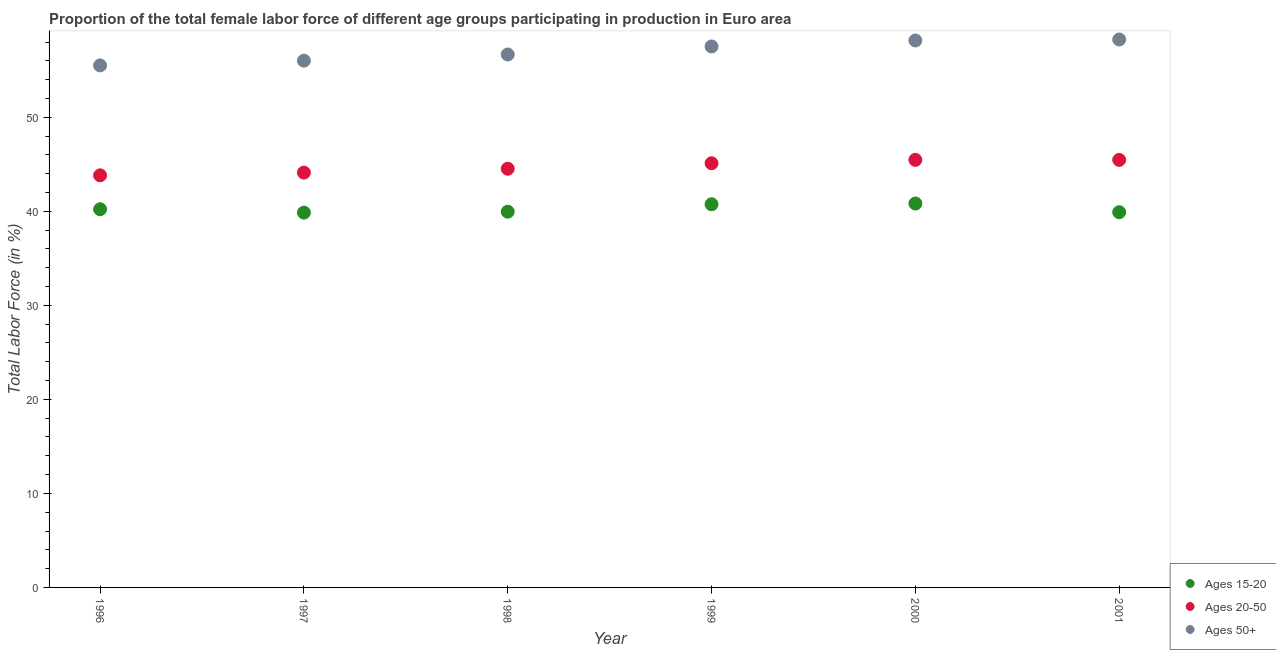What is the percentage of female labor force within the age group 15-20 in 2001?
Make the answer very short. 39.9. Across all years, what is the maximum percentage of female labor force within the age group 20-50?
Provide a short and direct response. 45.47. Across all years, what is the minimum percentage of female labor force within the age group 15-20?
Make the answer very short. 39.86. In which year was the percentage of female labor force above age 50 maximum?
Give a very brief answer. 2001. In which year was the percentage of female labor force within the age group 20-50 minimum?
Make the answer very short. 1996. What is the total percentage of female labor force within the age group 20-50 in the graph?
Ensure brevity in your answer.  268.5. What is the difference between the percentage of female labor force within the age group 15-20 in 1996 and that in 1998?
Ensure brevity in your answer.  0.26. What is the difference between the percentage of female labor force within the age group 15-20 in 2001 and the percentage of female labor force within the age group 20-50 in 1998?
Your answer should be compact. -4.62. What is the average percentage of female labor force above age 50 per year?
Make the answer very short. 57.03. In the year 2000, what is the difference between the percentage of female labor force above age 50 and percentage of female labor force within the age group 15-20?
Keep it short and to the point. 17.34. In how many years, is the percentage of female labor force within the age group 15-20 greater than 8 %?
Make the answer very short. 6. What is the ratio of the percentage of female labor force within the age group 20-50 in 1996 to that in 1999?
Provide a short and direct response. 0.97. What is the difference between the highest and the second highest percentage of female labor force above age 50?
Make the answer very short. 0.11. What is the difference between the highest and the lowest percentage of female labor force within the age group 20-50?
Your answer should be compact. 1.65. Is the sum of the percentage of female labor force within the age group 20-50 in 1998 and 1999 greater than the maximum percentage of female labor force within the age group 15-20 across all years?
Keep it short and to the point. Yes. Is it the case that in every year, the sum of the percentage of female labor force within the age group 15-20 and percentage of female labor force within the age group 20-50 is greater than the percentage of female labor force above age 50?
Your response must be concise. Yes. How many years are there in the graph?
Provide a short and direct response. 6. Are the values on the major ticks of Y-axis written in scientific E-notation?
Give a very brief answer. No. Does the graph contain any zero values?
Your response must be concise. No. Where does the legend appear in the graph?
Your response must be concise. Bottom right. How many legend labels are there?
Your response must be concise. 3. How are the legend labels stacked?
Offer a very short reply. Vertical. What is the title of the graph?
Provide a short and direct response. Proportion of the total female labor force of different age groups participating in production in Euro area. What is the label or title of the X-axis?
Give a very brief answer. Year. What is the label or title of the Y-axis?
Ensure brevity in your answer.  Total Labor Force (in %). What is the Total Labor Force (in %) of Ages 15-20 in 1996?
Your answer should be compact. 40.22. What is the Total Labor Force (in %) of Ages 20-50 in 1996?
Provide a succinct answer. 43.82. What is the Total Labor Force (in %) of Ages 50+ in 1996?
Provide a succinct answer. 55.51. What is the Total Labor Force (in %) of Ages 15-20 in 1997?
Provide a short and direct response. 39.86. What is the Total Labor Force (in %) in Ages 20-50 in 1997?
Provide a short and direct response. 44.11. What is the Total Labor Force (in %) of Ages 50+ in 1997?
Give a very brief answer. 56.02. What is the Total Labor Force (in %) in Ages 15-20 in 1998?
Ensure brevity in your answer.  39.96. What is the Total Labor Force (in %) of Ages 20-50 in 1998?
Offer a terse response. 44.52. What is the Total Labor Force (in %) of Ages 50+ in 1998?
Give a very brief answer. 56.67. What is the Total Labor Force (in %) of Ages 15-20 in 1999?
Provide a short and direct response. 40.75. What is the Total Labor Force (in %) in Ages 20-50 in 1999?
Offer a very short reply. 45.11. What is the Total Labor Force (in %) of Ages 50+ in 1999?
Offer a very short reply. 57.53. What is the Total Labor Force (in %) in Ages 15-20 in 2000?
Provide a short and direct response. 40.83. What is the Total Labor Force (in %) of Ages 20-50 in 2000?
Provide a succinct answer. 45.47. What is the Total Labor Force (in %) of Ages 50+ in 2000?
Provide a short and direct response. 58.16. What is the Total Labor Force (in %) of Ages 15-20 in 2001?
Make the answer very short. 39.9. What is the Total Labor Force (in %) in Ages 20-50 in 2001?
Ensure brevity in your answer.  45.46. What is the Total Labor Force (in %) of Ages 50+ in 2001?
Keep it short and to the point. 58.27. Across all years, what is the maximum Total Labor Force (in %) of Ages 15-20?
Provide a succinct answer. 40.83. Across all years, what is the maximum Total Labor Force (in %) of Ages 20-50?
Ensure brevity in your answer.  45.47. Across all years, what is the maximum Total Labor Force (in %) of Ages 50+?
Keep it short and to the point. 58.27. Across all years, what is the minimum Total Labor Force (in %) of Ages 15-20?
Offer a terse response. 39.86. Across all years, what is the minimum Total Labor Force (in %) of Ages 20-50?
Your answer should be very brief. 43.82. Across all years, what is the minimum Total Labor Force (in %) in Ages 50+?
Your answer should be compact. 55.51. What is the total Total Labor Force (in %) of Ages 15-20 in the graph?
Make the answer very short. 241.5. What is the total Total Labor Force (in %) of Ages 20-50 in the graph?
Your response must be concise. 268.5. What is the total Total Labor Force (in %) of Ages 50+ in the graph?
Provide a short and direct response. 342.15. What is the difference between the Total Labor Force (in %) in Ages 15-20 in 1996 and that in 1997?
Make the answer very short. 0.36. What is the difference between the Total Labor Force (in %) in Ages 20-50 in 1996 and that in 1997?
Ensure brevity in your answer.  -0.29. What is the difference between the Total Labor Force (in %) in Ages 50+ in 1996 and that in 1997?
Your response must be concise. -0.51. What is the difference between the Total Labor Force (in %) in Ages 15-20 in 1996 and that in 1998?
Your response must be concise. 0.26. What is the difference between the Total Labor Force (in %) in Ages 20-50 in 1996 and that in 1998?
Your response must be concise. -0.7. What is the difference between the Total Labor Force (in %) in Ages 50+ in 1996 and that in 1998?
Your answer should be compact. -1.16. What is the difference between the Total Labor Force (in %) of Ages 15-20 in 1996 and that in 1999?
Offer a terse response. -0.53. What is the difference between the Total Labor Force (in %) of Ages 20-50 in 1996 and that in 1999?
Offer a terse response. -1.28. What is the difference between the Total Labor Force (in %) of Ages 50+ in 1996 and that in 1999?
Offer a terse response. -2.02. What is the difference between the Total Labor Force (in %) in Ages 15-20 in 1996 and that in 2000?
Offer a terse response. -0.61. What is the difference between the Total Labor Force (in %) of Ages 20-50 in 1996 and that in 2000?
Keep it short and to the point. -1.65. What is the difference between the Total Labor Force (in %) of Ages 50+ in 1996 and that in 2000?
Make the answer very short. -2.65. What is the difference between the Total Labor Force (in %) in Ages 15-20 in 1996 and that in 2001?
Your response must be concise. 0.32. What is the difference between the Total Labor Force (in %) of Ages 20-50 in 1996 and that in 2001?
Give a very brief answer. -1.64. What is the difference between the Total Labor Force (in %) of Ages 50+ in 1996 and that in 2001?
Ensure brevity in your answer.  -2.76. What is the difference between the Total Labor Force (in %) in Ages 15-20 in 1997 and that in 1998?
Your answer should be compact. -0.1. What is the difference between the Total Labor Force (in %) of Ages 20-50 in 1997 and that in 1998?
Provide a short and direct response. -0.41. What is the difference between the Total Labor Force (in %) in Ages 50+ in 1997 and that in 1998?
Offer a terse response. -0.65. What is the difference between the Total Labor Force (in %) in Ages 15-20 in 1997 and that in 1999?
Your answer should be compact. -0.89. What is the difference between the Total Labor Force (in %) of Ages 20-50 in 1997 and that in 1999?
Offer a terse response. -0.99. What is the difference between the Total Labor Force (in %) of Ages 50+ in 1997 and that in 1999?
Offer a very short reply. -1.51. What is the difference between the Total Labor Force (in %) of Ages 15-20 in 1997 and that in 2000?
Your answer should be very brief. -0.97. What is the difference between the Total Labor Force (in %) of Ages 20-50 in 1997 and that in 2000?
Keep it short and to the point. -1.35. What is the difference between the Total Labor Force (in %) in Ages 50+ in 1997 and that in 2000?
Keep it short and to the point. -2.15. What is the difference between the Total Labor Force (in %) in Ages 15-20 in 1997 and that in 2001?
Provide a succinct answer. -0.04. What is the difference between the Total Labor Force (in %) of Ages 20-50 in 1997 and that in 2001?
Give a very brief answer. -1.35. What is the difference between the Total Labor Force (in %) of Ages 50+ in 1997 and that in 2001?
Your answer should be compact. -2.25. What is the difference between the Total Labor Force (in %) in Ages 15-20 in 1998 and that in 1999?
Your answer should be compact. -0.79. What is the difference between the Total Labor Force (in %) of Ages 20-50 in 1998 and that in 1999?
Keep it short and to the point. -0.58. What is the difference between the Total Labor Force (in %) of Ages 50+ in 1998 and that in 1999?
Give a very brief answer. -0.85. What is the difference between the Total Labor Force (in %) of Ages 15-20 in 1998 and that in 2000?
Give a very brief answer. -0.87. What is the difference between the Total Labor Force (in %) of Ages 20-50 in 1998 and that in 2000?
Offer a terse response. -0.94. What is the difference between the Total Labor Force (in %) in Ages 50+ in 1998 and that in 2000?
Offer a terse response. -1.49. What is the difference between the Total Labor Force (in %) of Ages 15-20 in 1998 and that in 2001?
Make the answer very short. 0.06. What is the difference between the Total Labor Force (in %) in Ages 20-50 in 1998 and that in 2001?
Offer a very short reply. -0.94. What is the difference between the Total Labor Force (in %) in Ages 50+ in 1998 and that in 2001?
Provide a short and direct response. -1.6. What is the difference between the Total Labor Force (in %) in Ages 15-20 in 1999 and that in 2000?
Offer a terse response. -0.08. What is the difference between the Total Labor Force (in %) in Ages 20-50 in 1999 and that in 2000?
Provide a short and direct response. -0.36. What is the difference between the Total Labor Force (in %) of Ages 50+ in 1999 and that in 2000?
Your response must be concise. -0.64. What is the difference between the Total Labor Force (in %) in Ages 15-20 in 1999 and that in 2001?
Ensure brevity in your answer.  0.85. What is the difference between the Total Labor Force (in %) of Ages 20-50 in 1999 and that in 2001?
Keep it short and to the point. -0.36. What is the difference between the Total Labor Force (in %) in Ages 50+ in 1999 and that in 2001?
Ensure brevity in your answer.  -0.74. What is the difference between the Total Labor Force (in %) of Ages 15-20 in 2000 and that in 2001?
Offer a terse response. 0.93. What is the difference between the Total Labor Force (in %) of Ages 20-50 in 2000 and that in 2001?
Provide a short and direct response. 0. What is the difference between the Total Labor Force (in %) of Ages 50+ in 2000 and that in 2001?
Give a very brief answer. -0.11. What is the difference between the Total Labor Force (in %) in Ages 15-20 in 1996 and the Total Labor Force (in %) in Ages 20-50 in 1997?
Ensure brevity in your answer.  -3.9. What is the difference between the Total Labor Force (in %) in Ages 15-20 in 1996 and the Total Labor Force (in %) in Ages 50+ in 1997?
Your answer should be compact. -15.8. What is the difference between the Total Labor Force (in %) in Ages 20-50 in 1996 and the Total Labor Force (in %) in Ages 50+ in 1997?
Offer a very short reply. -12.2. What is the difference between the Total Labor Force (in %) of Ages 15-20 in 1996 and the Total Labor Force (in %) of Ages 20-50 in 1998?
Offer a very short reply. -4.31. What is the difference between the Total Labor Force (in %) in Ages 15-20 in 1996 and the Total Labor Force (in %) in Ages 50+ in 1998?
Provide a short and direct response. -16.45. What is the difference between the Total Labor Force (in %) in Ages 20-50 in 1996 and the Total Labor Force (in %) in Ages 50+ in 1998?
Your answer should be very brief. -12.85. What is the difference between the Total Labor Force (in %) in Ages 15-20 in 1996 and the Total Labor Force (in %) in Ages 20-50 in 1999?
Offer a very short reply. -4.89. What is the difference between the Total Labor Force (in %) of Ages 15-20 in 1996 and the Total Labor Force (in %) of Ages 50+ in 1999?
Keep it short and to the point. -17.31. What is the difference between the Total Labor Force (in %) in Ages 20-50 in 1996 and the Total Labor Force (in %) in Ages 50+ in 1999?
Give a very brief answer. -13.7. What is the difference between the Total Labor Force (in %) in Ages 15-20 in 1996 and the Total Labor Force (in %) in Ages 20-50 in 2000?
Provide a short and direct response. -5.25. What is the difference between the Total Labor Force (in %) in Ages 15-20 in 1996 and the Total Labor Force (in %) in Ages 50+ in 2000?
Give a very brief answer. -17.94. What is the difference between the Total Labor Force (in %) of Ages 20-50 in 1996 and the Total Labor Force (in %) of Ages 50+ in 2000?
Your answer should be compact. -14.34. What is the difference between the Total Labor Force (in %) of Ages 15-20 in 1996 and the Total Labor Force (in %) of Ages 20-50 in 2001?
Your answer should be compact. -5.25. What is the difference between the Total Labor Force (in %) of Ages 15-20 in 1996 and the Total Labor Force (in %) of Ages 50+ in 2001?
Your response must be concise. -18.05. What is the difference between the Total Labor Force (in %) in Ages 20-50 in 1996 and the Total Labor Force (in %) in Ages 50+ in 2001?
Provide a succinct answer. -14.45. What is the difference between the Total Labor Force (in %) of Ages 15-20 in 1997 and the Total Labor Force (in %) of Ages 20-50 in 1998?
Ensure brevity in your answer.  -4.67. What is the difference between the Total Labor Force (in %) of Ages 15-20 in 1997 and the Total Labor Force (in %) of Ages 50+ in 1998?
Make the answer very short. -16.81. What is the difference between the Total Labor Force (in %) of Ages 20-50 in 1997 and the Total Labor Force (in %) of Ages 50+ in 1998?
Keep it short and to the point. -12.56. What is the difference between the Total Labor Force (in %) in Ages 15-20 in 1997 and the Total Labor Force (in %) in Ages 20-50 in 1999?
Ensure brevity in your answer.  -5.25. What is the difference between the Total Labor Force (in %) of Ages 15-20 in 1997 and the Total Labor Force (in %) of Ages 50+ in 1999?
Make the answer very short. -17.67. What is the difference between the Total Labor Force (in %) of Ages 20-50 in 1997 and the Total Labor Force (in %) of Ages 50+ in 1999?
Your response must be concise. -13.41. What is the difference between the Total Labor Force (in %) in Ages 15-20 in 1997 and the Total Labor Force (in %) in Ages 20-50 in 2000?
Offer a very short reply. -5.61. What is the difference between the Total Labor Force (in %) of Ages 15-20 in 1997 and the Total Labor Force (in %) of Ages 50+ in 2000?
Your response must be concise. -18.3. What is the difference between the Total Labor Force (in %) of Ages 20-50 in 1997 and the Total Labor Force (in %) of Ages 50+ in 2000?
Your answer should be compact. -14.05. What is the difference between the Total Labor Force (in %) in Ages 15-20 in 1997 and the Total Labor Force (in %) in Ages 20-50 in 2001?
Make the answer very short. -5.61. What is the difference between the Total Labor Force (in %) in Ages 15-20 in 1997 and the Total Labor Force (in %) in Ages 50+ in 2001?
Offer a terse response. -18.41. What is the difference between the Total Labor Force (in %) in Ages 20-50 in 1997 and the Total Labor Force (in %) in Ages 50+ in 2001?
Keep it short and to the point. -14.16. What is the difference between the Total Labor Force (in %) of Ages 15-20 in 1998 and the Total Labor Force (in %) of Ages 20-50 in 1999?
Provide a short and direct response. -5.15. What is the difference between the Total Labor Force (in %) of Ages 15-20 in 1998 and the Total Labor Force (in %) of Ages 50+ in 1999?
Your response must be concise. -17.57. What is the difference between the Total Labor Force (in %) of Ages 20-50 in 1998 and the Total Labor Force (in %) of Ages 50+ in 1999?
Keep it short and to the point. -13. What is the difference between the Total Labor Force (in %) in Ages 15-20 in 1998 and the Total Labor Force (in %) in Ages 20-50 in 2000?
Offer a terse response. -5.51. What is the difference between the Total Labor Force (in %) of Ages 15-20 in 1998 and the Total Labor Force (in %) of Ages 50+ in 2000?
Your answer should be very brief. -18.2. What is the difference between the Total Labor Force (in %) in Ages 20-50 in 1998 and the Total Labor Force (in %) in Ages 50+ in 2000?
Offer a very short reply. -13.64. What is the difference between the Total Labor Force (in %) of Ages 15-20 in 1998 and the Total Labor Force (in %) of Ages 20-50 in 2001?
Provide a succinct answer. -5.51. What is the difference between the Total Labor Force (in %) in Ages 15-20 in 1998 and the Total Labor Force (in %) in Ages 50+ in 2001?
Offer a terse response. -18.31. What is the difference between the Total Labor Force (in %) in Ages 20-50 in 1998 and the Total Labor Force (in %) in Ages 50+ in 2001?
Your response must be concise. -13.74. What is the difference between the Total Labor Force (in %) of Ages 15-20 in 1999 and the Total Labor Force (in %) of Ages 20-50 in 2000?
Your answer should be compact. -4.72. What is the difference between the Total Labor Force (in %) of Ages 15-20 in 1999 and the Total Labor Force (in %) of Ages 50+ in 2000?
Your answer should be compact. -17.42. What is the difference between the Total Labor Force (in %) in Ages 20-50 in 1999 and the Total Labor Force (in %) in Ages 50+ in 2000?
Make the answer very short. -13.06. What is the difference between the Total Labor Force (in %) of Ages 15-20 in 1999 and the Total Labor Force (in %) of Ages 20-50 in 2001?
Ensure brevity in your answer.  -4.72. What is the difference between the Total Labor Force (in %) of Ages 15-20 in 1999 and the Total Labor Force (in %) of Ages 50+ in 2001?
Offer a terse response. -17.52. What is the difference between the Total Labor Force (in %) in Ages 20-50 in 1999 and the Total Labor Force (in %) in Ages 50+ in 2001?
Your answer should be very brief. -13.16. What is the difference between the Total Labor Force (in %) in Ages 15-20 in 2000 and the Total Labor Force (in %) in Ages 20-50 in 2001?
Offer a terse response. -4.64. What is the difference between the Total Labor Force (in %) in Ages 15-20 in 2000 and the Total Labor Force (in %) in Ages 50+ in 2001?
Offer a very short reply. -17.44. What is the difference between the Total Labor Force (in %) in Ages 20-50 in 2000 and the Total Labor Force (in %) in Ages 50+ in 2001?
Provide a succinct answer. -12.8. What is the average Total Labor Force (in %) of Ages 15-20 per year?
Keep it short and to the point. 40.25. What is the average Total Labor Force (in %) of Ages 20-50 per year?
Provide a succinct answer. 44.75. What is the average Total Labor Force (in %) of Ages 50+ per year?
Offer a terse response. 57.03. In the year 1996, what is the difference between the Total Labor Force (in %) of Ages 15-20 and Total Labor Force (in %) of Ages 20-50?
Make the answer very short. -3.6. In the year 1996, what is the difference between the Total Labor Force (in %) of Ages 15-20 and Total Labor Force (in %) of Ages 50+?
Offer a terse response. -15.29. In the year 1996, what is the difference between the Total Labor Force (in %) in Ages 20-50 and Total Labor Force (in %) in Ages 50+?
Ensure brevity in your answer.  -11.69. In the year 1997, what is the difference between the Total Labor Force (in %) in Ages 15-20 and Total Labor Force (in %) in Ages 20-50?
Make the answer very short. -4.26. In the year 1997, what is the difference between the Total Labor Force (in %) in Ages 15-20 and Total Labor Force (in %) in Ages 50+?
Provide a short and direct response. -16.16. In the year 1997, what is the difference between the Total Labor Force (in %) of Ages 20-50 and Total Labor Force (in %) of Ages 50+?
Make the answer very short. -11.9. In the year 1998, what is the difference between the Total Labor Force (in %) in Ages 15-20 and Total Labor Force (in %) in Ages 20-50?
Offer a terse response. -4.57. In the year 1998, what is the difference between the Total Labor Force (in %) of Ages 15-20 and Total Labor Force (in %) of Ages 50+?
Make the answer very short. -16.71. In the year 1998, what is the difference between the Total Labor Force (in %) of Ages 20-50 and Total Labor Force (in %) of Ages 50+?
Make the answer very short. -12.15. In the year 1999, what is the difference between the Total Labor Force (in %) in Ages 15-20 and Total Labor Force (in %) in Ages 20-50?
Give a very brief answer. -4.36. In the year 1999, what is the difference between the Total Labor Force (in %) in Ages 15-20 and Total Labor Force (in %) in Ages 50+?
Offer a very short reply. -16.78. In the year 1999, what is the difference between the Total Labor Force (in %) of Ages 20-50 and Total Labor Force (in %) of Ages 50+?
Make the answer very short. -12.42. In the year 2000, what is the difference between the Total Labor Force (in %) of Ages 15-20 and Total Labor Force (in %) of Ages 20-50?
Provide a succinct answer. -4.64. In the year 2000, what is the difference between the Total Labor Force (in %) of Ages 15-20 and Total Labor Force (in %) of Ages 50+?
Your answer should be very brief. -17.34. In the year 2000, what is the difference between the Total Labor Force (in %) in Ages 20-50 and Total Labor Force (in %) in Ages 50+?
Give a very brief answer. -12.69. In the year 2001, what is the difference between the Total Labor Force (in %) of Ages 15-20 and Total Labor Force (in %) of Ages 20-50?
Keep it short and to the point. -5.56. In the year 2001, what is the difference between the Total Labor Force (in %) of Ages 15-20 and Total Labor Force (in %) of Ages 50+?
Offer a very short reply. -18.37. In the year 2001, what is the difference between the Total Labor Force (in %) of Ages 20-50 and Total Labor Force (in %) of Ages 50+?
Make the answer very short. -12.8. What is the ratio of the Total Labor Force (in %) of Ages 20-50 in 1996 to that in 1997?
Your answer should be very brief. 0.99. What is the ratio of the Total Labor Force (in %) in Ages 15-20 in 1996 to that in 1998?
Provide a succinct answer. 1.01. What is the ratio of the Total Labor Force (in %) in Ages 20-50 in 1996 to that in 1998?
Provide a succinct answer. 0.98. What is the ratio of the Total Labor Force (in %) of Ages 50+ in 1996 to that in 1998?
Make the answer very short. 0.98. What is the ratio of the Total Labor Force (in %) in Ages 20-50 in 1996 to that in 1999?
Give a very brief answer. 0.97. What is the ratio of the Total Labor Force (in %) in Ages 50+ in 1996 to that in 1999?
Your answer should be very brief. 0.96. What is the ratio of the Total Labor Force (in %) in Ages 15-20 in 1996 to that in 2000?
Give a very brief answer. 0.99. What is the ratio of the Total Labor Force (in %) of Ages 20-50 in 1996 to that in 2000?
Give a very brief answer. 0.96. What is the ratio of the Total Labor Force (in %) in Ages 50+ in 1996 to that in 2000?
Your answer should be compact. 0.95. What is the ratio of the Total Labor Force (in %) in Ages 15-20 in 1996 to that in 2001?
Provide a short and direct response. 1.01. What is the ratio of the Total Labor Force (in %) of Ages 20-50 in 1996 to that in 2001?
Provide a short and direct response. 0.96. What is the ratio of the Total Labor Force (in %) in Ages 50+ in 1996 to that in 2001?
Keep it short and to the point. 0.95. What is the ratio of the Total Labor Force (in %) of Ages 20-50 in 1997 to that in 1998?
Provide a succinct answer. 0.99. What is the ratio of the Total Labor Force (in %) of Ages 50+ in 1997 to that in 1998?
Make the answer very short. 0.99. What is the ratio of the Total Labor Force (in %) in Ages 15-20 in 1997 to that in 1999?
Ensure brevity in your answer.  0.98. What is the ratio of the Total Labor Force (in %) of Ages 20-50 in 1997 to that in 1999?
Your response must be concise. 0.98. What is the ratio of the Total Labor Force (in %) in Ages 50+ in 1997 to that in 1999?
Your answer should be compact. 0.97. What is the ratio of the Total Labor Force (in %) in Ages 15-20 in 1997 to that in 2000?
Make the answer very short. 0.98. What is the ratio of the Total Labor Force (in %) in Ages 20-50 in 1997 to that in 2000?
Provide a succinct answer. 0.97. What is the ratio of the Total Labor Force (in %) in Ages 50+ in 1997 to that in 2000?
Give a very brief answer. 0.96. What is the ratio of the Total Labor Force (in %) of Ages 20-50 in 1997 to that in 2001?
Your response must be concise. 0.97. What is the ratio of the Total Labor Force (in %) in Ages 50+ in 1997 to that in 2001?
Your answer should be very brief. 0.96. What is the ratio of the Total Labor Force (in %) of Ages 15-20 in 1998 to that in 1999?
Provide a short and direct response. 0.98. What is the ratio of the Total Labor Force (in %) in Ages 20-50 in 1998 to that in 1999?
Make the answer very short. 0.99. What is the ratio of the Total Labor Force (in %) of Ages 50+ in 1998 to that in 1999?
Provide a succinct answer. 0.99. What is the ratio of the Total Labor Force (in %) of Ages 15-20 in 1998 to that in 2000?
Offer a very short reply. 0.98. What is the ratio of the Total Labor Force (in %) in Ages 20-50 in 1998 to that in 2000?
Provide a succinct answer. 0.98. What is the ratio of the Total Labor Force (in %) of Ages 50+ in 1998 to that in 2000?
Provide a succinct answer. 0.97. What is the ratio of the Total Labor Force (in %) in Ages 15-20 in 1998 to that in 2001?
Ensure brevity in your answer.  1. What is the ratio of the Total Labor Force (in %) of Ages 20-50 in 1998 to that in 2001?
Provide a short and direct response. 0.98. What is the ratio of the Total Labor Force (in %) of Ages 50+ in 1998 to that in 2001?
Your response must be concise. 0.97. What is the ratio of the Total Labor Force (in %) of Ages 20-50 in 1999 to that in 2000?
Offer a very short reply. 0.99. What is the ratio of the Total Labor Force (in %) in Ages 50+ in 1999 to that in 2000?
Your response must be concise. 0.99. What is the ratio of the Total Labor Force (in %) of Ages 15-20 in 1999 to that in 2001?
Your answer should be very brief. 1.02. What is the ratio of the Total Labor Force (in %) in Ages 50+ in 1999 to that in 2001?
Keep it short and to the point. 0.99. What is the ratio of the Total Labor Force (in %) in Ages 15-20 in 2000 to that in 2001?
Make the answer very short. 1.02. What is the ratio of the Total Labor Force (in %) in Ages 20-50 in 2000 to that in 2001?
Offer a very short reply. 1. What is the ratio of the Total Labor Force (in %) of Ages 50+ in 2000 to that in 2001?
Your response must be concise. 1. What is the difference between the highest and the second highest Total Labor Force (in %) of Ages 15-20?
Offer a very short reply. 0.08. What is the difference between the highest and the second highest Total Labor Force (in %) of Ages 20-50?
Your response must be concise. 0. What is the difference between the highest and the second highest Total Labor Force (in %) in Ages 50+?
Make the answer very short. 0.11. What is the difference between the highest and the lowest Total Labor Force (in %) in Ages 15-20?
Give a very brief answer. 0.97. What is the difference between the highest and the lowest Total Labor Force (in %) in Ages 20-50?
Give a very brief answer. 1.65. What is the difference between the highest and the lowest Total Labor Force (in %) in Ages 50+?
Your answer should be very brief. 2.76. 